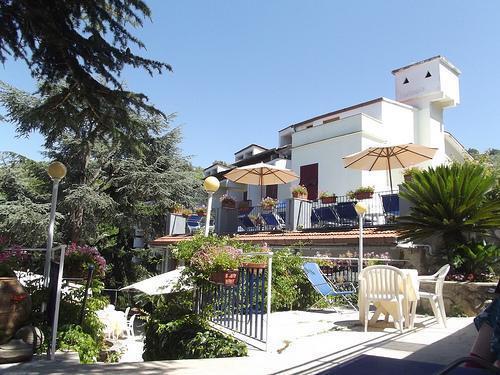How many umbrellas are there?
Give a very brief answer. 2. How many light posts are there?
Give a very brief answer. 3. 